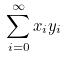<formula> <loc_0><loc_0><loc_500><loc_500>\sum _ { i = 0 } ^ { \infty } x _ { i } y _ { i }</formula> 